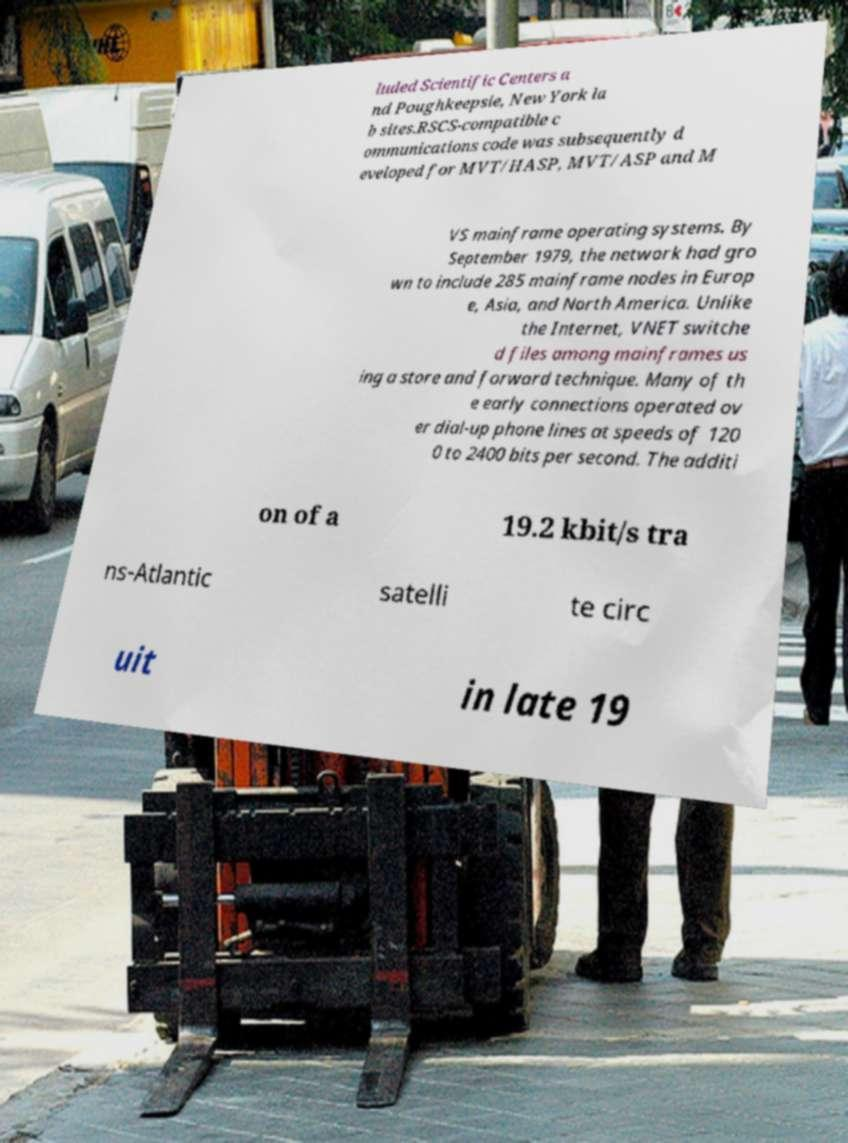There's text embedded in this image that I need extracted. Can you transcribe it verbatim? luded Scientific Centers a nd Poughkeepsie, New York la b sites.RSCS-compatible c ommunications code was subsequently d eveloped for MVT/HASP, MVT/ASP and M VS mainframe operating systems. By September 1979, the network had gro wn to include 285 mainframe nodes in Europ e, Asia, and North America. Unlike the Internet, VNET switche d files among mainframes us ing a store and forward technique. Many of th e early connections operated ov er dial-up phone lines at speeds of 120 0 to 2400 bits per second. The additi on of a 19.2 kbit/s tra ns-Atlantic satelli te circ uit in late 19 